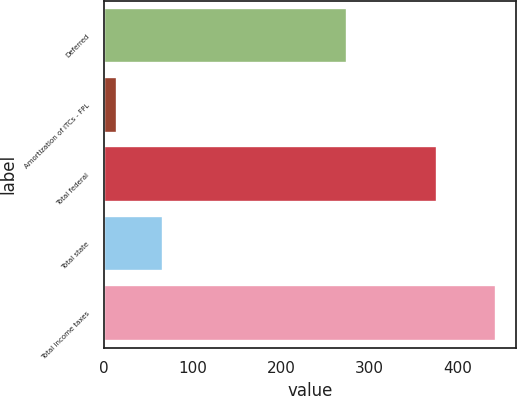Convert chart. <chart><loc_0><loc_0><loc_500><loc_500><bar_chart><fcel>Deferred<fcel>Amortization of ITCs - FPL<fcel>Total federal<fcel>Total state<fcel>Total income taxes<nl><fcel>274<fcel>15<fcel>376<fcel>67<fcel>443<nl></chart> 